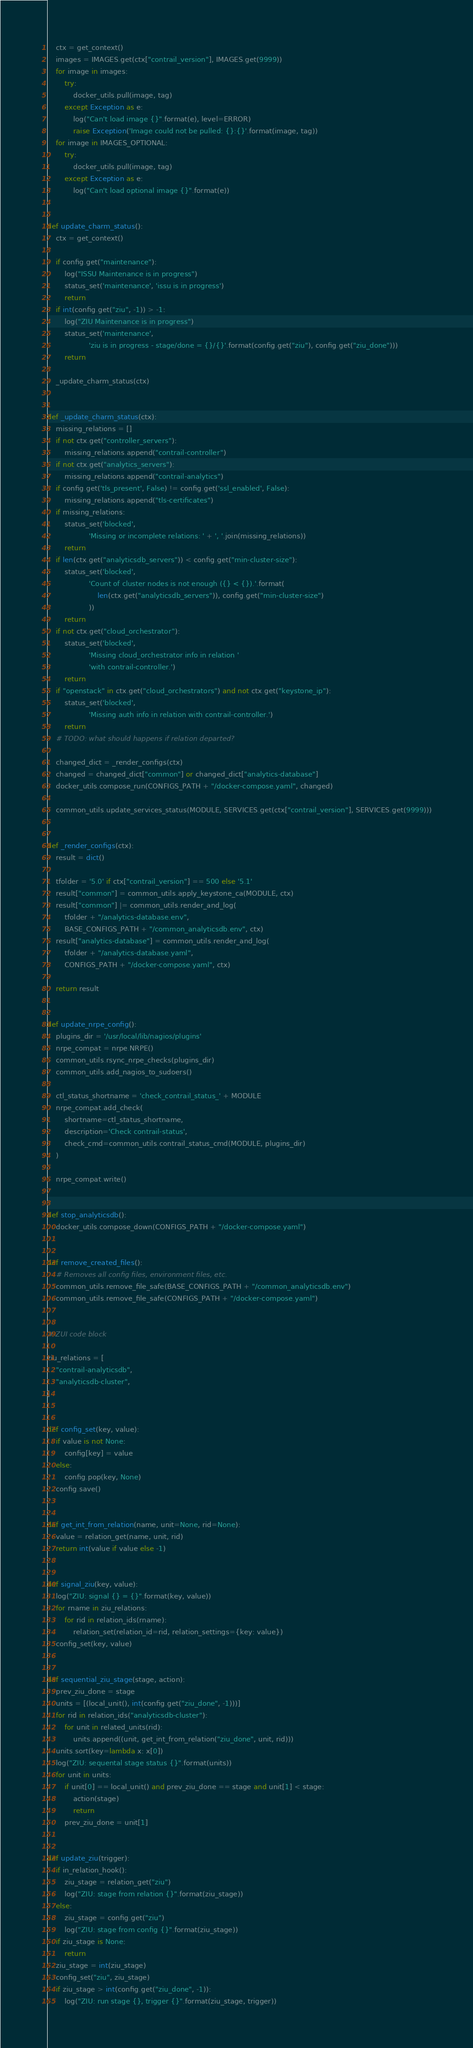<code> <loc_0><loc_0><loc_500><loc_500><_Python_>    ctx = get_context()
    images = IMAGES.get(ctx["contrail_version"], IMAGES.get(9999))
    for image in images:
        try:
            docker_utils.pull(image, tag)
        except Exception as e:
            log("Can't load image {}".format(e), level=ERROR)
            raise Exception('Image could not be pulled: {}:{}'.format(image, tag))
    for image in IMAGES_OPTIONAL:
        try:
            docker_utils.pull(image, tag)
        except Exception as e:
            log("Can't load optional image {}".format(e))


def update_charm_status():
    ctx = get_context()

    if config.get("maintenance"):
        log("ISSU Maintenance is in progress")
        status_set('maintenance', 'issu is in progress')
        return
    if int(config.get("ziu", -1)) > -1:
        log("ZIU Maintenance is in progress")
        status_set('maintenance',
                   'ziu is in progress - stage/done = {}/{}'.format(config.get("ziu"), config.get("ziu_done")))
        return

    _update_charm_status(ctx)


def _update_charm_status(ctx):
    missing_relations = []
    if not ctx.get("controller_servers"):
        missing_relations.append("contrail-controller")
    if not ctx.get("analytics_servers"):
        missing_relations.append("contrail-analytics")
    if config.get('tls_present', False) != config.get('ssl_enabled', False):
        missing_relations.append("tls-certificates")
    if missing_relations:
        status_set('blocked',
                   'Missing or incomplete relations: ' + ', '.join(missing_relations))
        return
    if len(ctx.get("analyticsdb_servers")) < config.get("min-cluster-size"):
        status_set('blocked',
                   'Count of cluster nodes is not enough ({} < {}).'.format(
                       len(ctx.get("analyticsdb_servers")), config.get("min-cluster-size")
                   ))
        return
    if not ctx.get("cloud_orchestrator"):
        status_set('blocked',
                   'Missing cloud_orchestrator info in relation '
                   'with contrail-controller.')
        return
    if "openstack" in ctx.get("cloud_orchestrators") and not ctx.get("keystone_ip"):
        status_set('blocked',
                   'Missing auth info in relation with contrail-controller.')
        return
    # TODO: what should happens if relation departed?

    changed_dict = _render_configs(ctx)
    changed = changed_dict["common"] or changed_dict["analytics-database"]
    docker_utils.compose_run(CONFIGS_PATH + "/docker-compose.yaml", changed)

    common_utils.update_services_status(MODULE, SERVICES.get(ctx["contrail_version"], SERVICES.get(9999)))


def _render_configs(ctx):
    result = dict()

    tfolder = '5.0' if ctx["contrail_version"] == 500 else '5.1'
    result["common"] = common_utils.apply_keystone_ca(MODULE, ctx)
    result["common"] |= common_utils.render_and_log(
        tfolder + "/analytics-database.env",
        BASE_CONFIGS_PATH + "/common_analyticsdb.env", ctx)
    result["analytics-database"] = common_utils.render_and_log(
        tfolder + "/analytics-database.yaml",
        CONFIGS_PATH + "/docker-compose.yaml", ctx)

    return result


def update_nrpe_config():
    plugins_dir = '/usr/local/lib/nagios/plugins'
    nrpe_compat = nrpe.NRPE()
    common_utils.rsync_nrpe_checks(plugins_dir)
    common_utils.add_nagios_to_sudoers()

    ctl_status_shortname = 'check_contrail_status_' + MODULE
    nrpe_compat.add_check(
        shortname=ctl_status_shortname,
        description='Check contrail-status',
        check_cmd=common_utils.contrail_status_cmd(MODULE, plugins_dir)
    )

    nrpe_compat.write()


def stop_analyticsdb():
    docker_utils.compose_down(CONFIGS_PATH + "/docker-compose.yaml")


def remove_created_files():
    # Removes all config files, environment files, etc.
    common_utils.remove_file_safe(BASE_CONFIGS_PATH + "/common_analyticsdb.env")
    common_utils.remove_file_safe(CONFIGS_PATH + "/docker-compose.yaml")


# ZUI code block

ziu_relations = [
    "contrail-analyticsdb",
    "analyticsdb-cluster",
]


def config_set(key, value):
    if value is not None:
        config[key] = value
    else:
        config.pop(key, None)
    config.save()


def get_int_from_relation(name, unit=None, rid=None):
    value = relation_get(name, unit, rid)
    return int(value if value else -1)


def signal_ziu(key, value):
    log("ZIU: signal {} = {}".format(key, value))
    for rname in ziu_relations:
        for rid in relation_ids(rname):
            relation_set(relation_id=rid, relation_settings={key: value})
    config_set(key, value)


def sequential_ziu_stage(stage, action):
    prev_ziu_done = stage
    units = [(local_unit(), int(config.get("ziu_done", -1)))]
    for rid in relation_ids("analyticsdb-cluster"):
        for unit in related_units(rid):
            units.append((unit, get_int_from_relation("ziu_done", unit, rid)))
    units.sort(key=lambda x: x[0])
    log("ZIU: sequental stage status {}".format(units))
    for unit in units:
        if unit[0] == local_unit() and prev_ziu_done == stage and unit[1] < stage:
            action(stage)
            return
        prev_ziu_done = unit[1]


def update_ziu(trigger):
    if in_relation_hook():
        ziu_stage = relation_get("ziu")
        log("ZIU: stage from relation {}".format(ziu_stage))
    else:
        ziu_stage = config.get("ziu")
        log("ZIU: stage from config {}".format(ziu_stage))
    if ziu_stage is None:
        return
    ziu_stage = int(ziu_stage)
    config_set("ziu", ziu_stage)
    if ziu_stage > int(config.get("ziu_done", -1)):
        log("ZIU: run stage {}, trigger {}".format(ziu_stage, trigger))</code> 